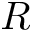<formula> <loc_0><loc_0><loc_500><loc_500>R</formula> 